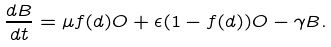<formula> <loc_0><loc_0><loc_500><loc_500>\frac { d B } { d t } = \mu f ( d ) O + \epsilon ( 1 - f ( d ) ) O - \gamma B .</formula> 